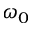<formula> <loc_0><loc_0><loc_500><loc_500>\omega _ { 0 }</formula> 